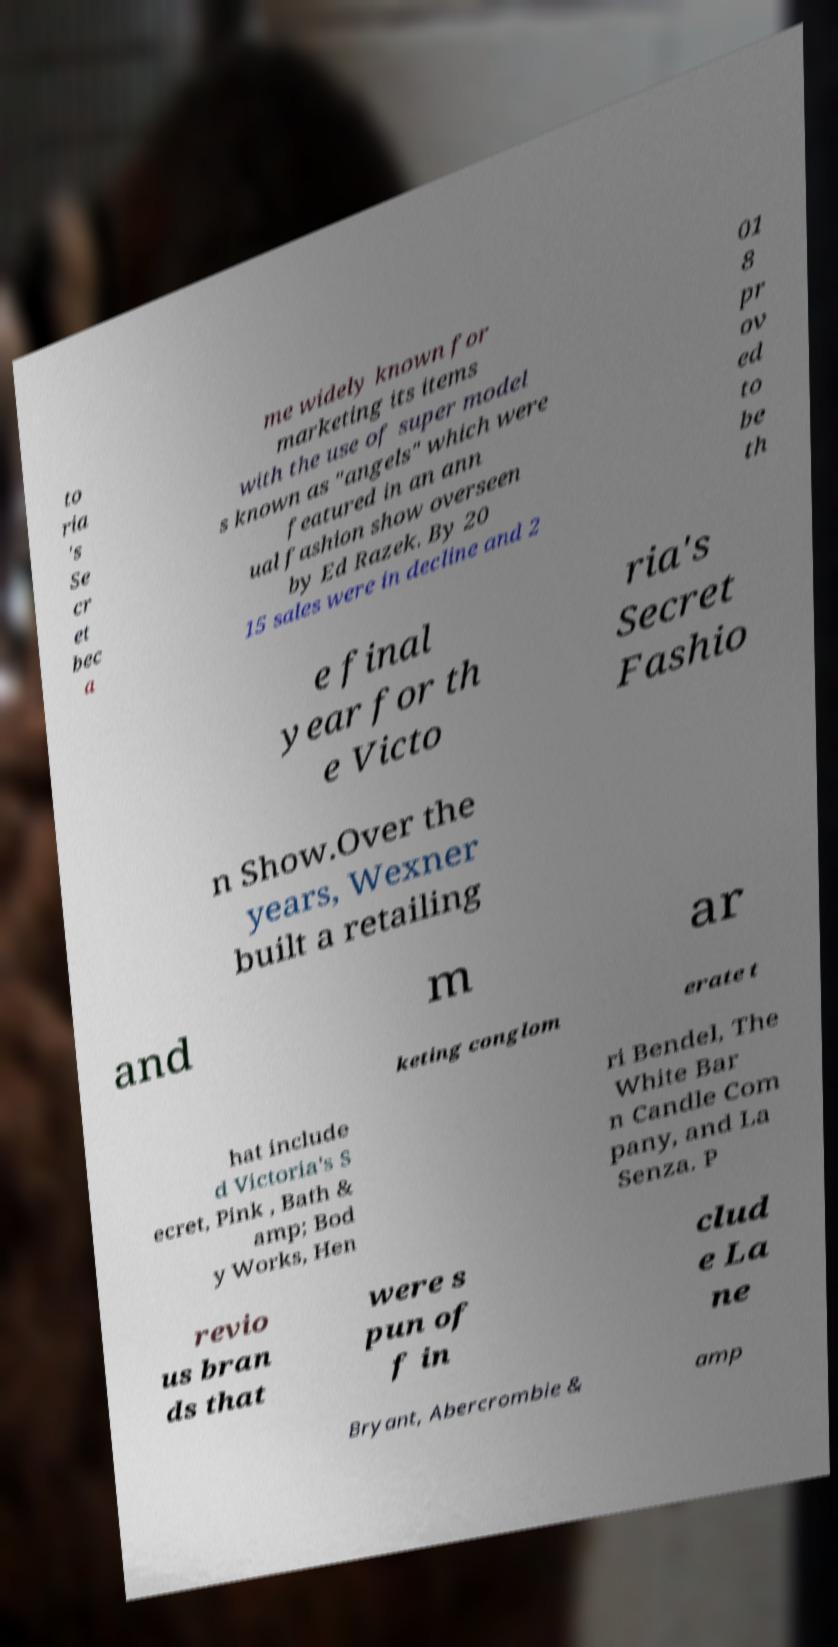Could you extract and type out the text from this image? to ria 's Se cr et bec a me widely known for marketing its items with the use of super model s known as "angels" which were featured in an ann ual fashion show overseen by Ed Razek. By 20 15 sales were in decline and 2 01 8 pr ov ed to be th e final year for th e Victo ria's Secret Fashio n Show.Over the years, Wexner built a retailing and m ar keting conglom erate t hat include d Victoria's S ecret, Pink , Bath & amp; Bod y Works, Hen ri Bendel, The White Bar n Candle Com pany, and La Senza. P revio us bran ds that were s pun of f in clud e La ne Bryant, Abercrombie & amp 